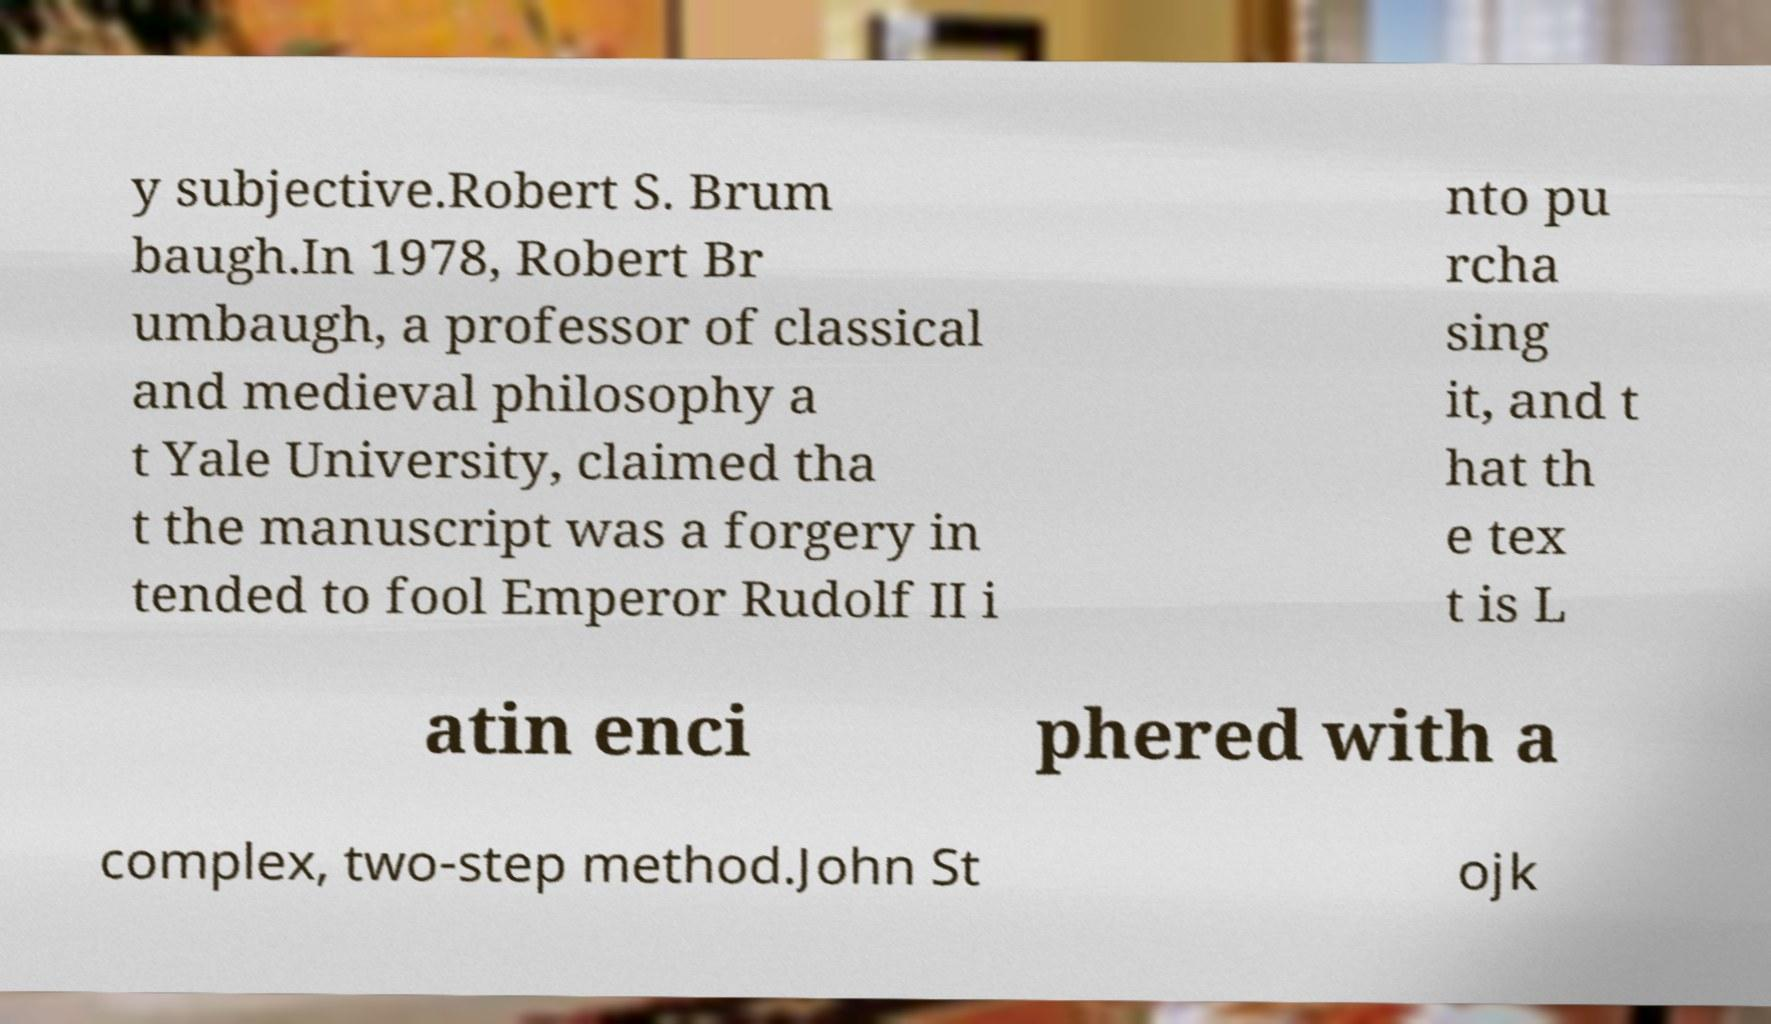Please read and relay the text visible in this image. What does it say? y subjective.Robert S. Brum baugh.In 1978, Robert Br umbaugh, a professor of classical and medieval philosophy a t Yale University, claimed tha t the manuscript was a forgery in tended to fool Emperor Rudolf II i nto pu rcha sing it, and t hat th e tex t is L atin enci phered with a complex, two-step method.John St ojk 